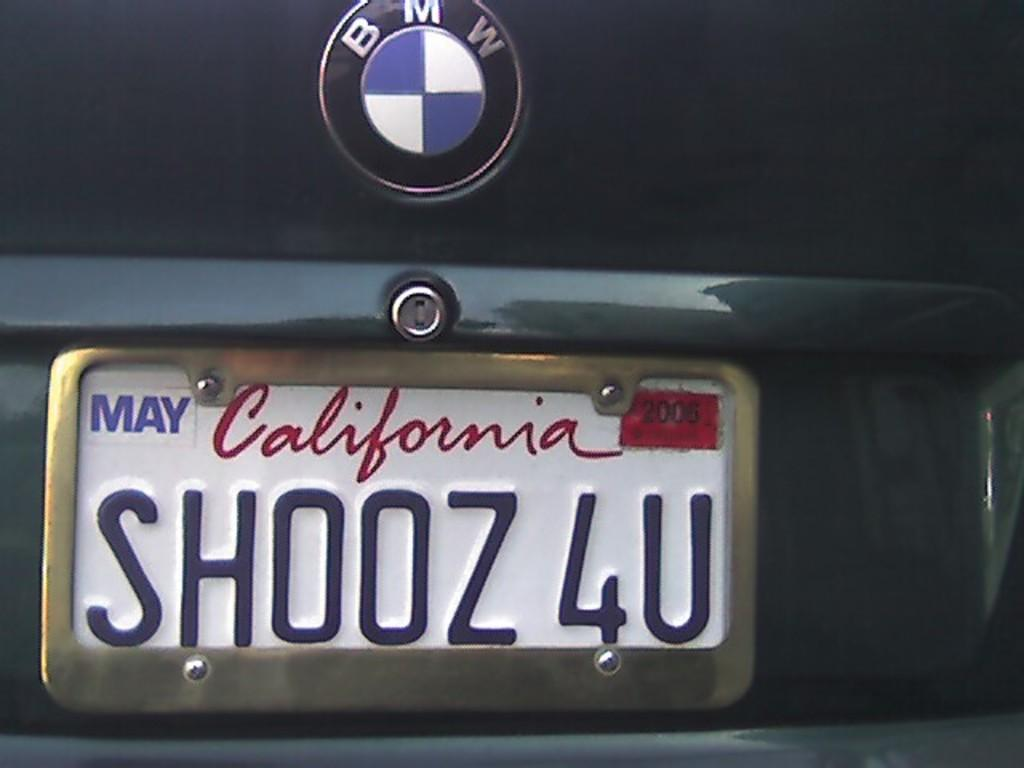Provide a one-sentence caption for the provided image. a license plate that has shooz 4u on it. 